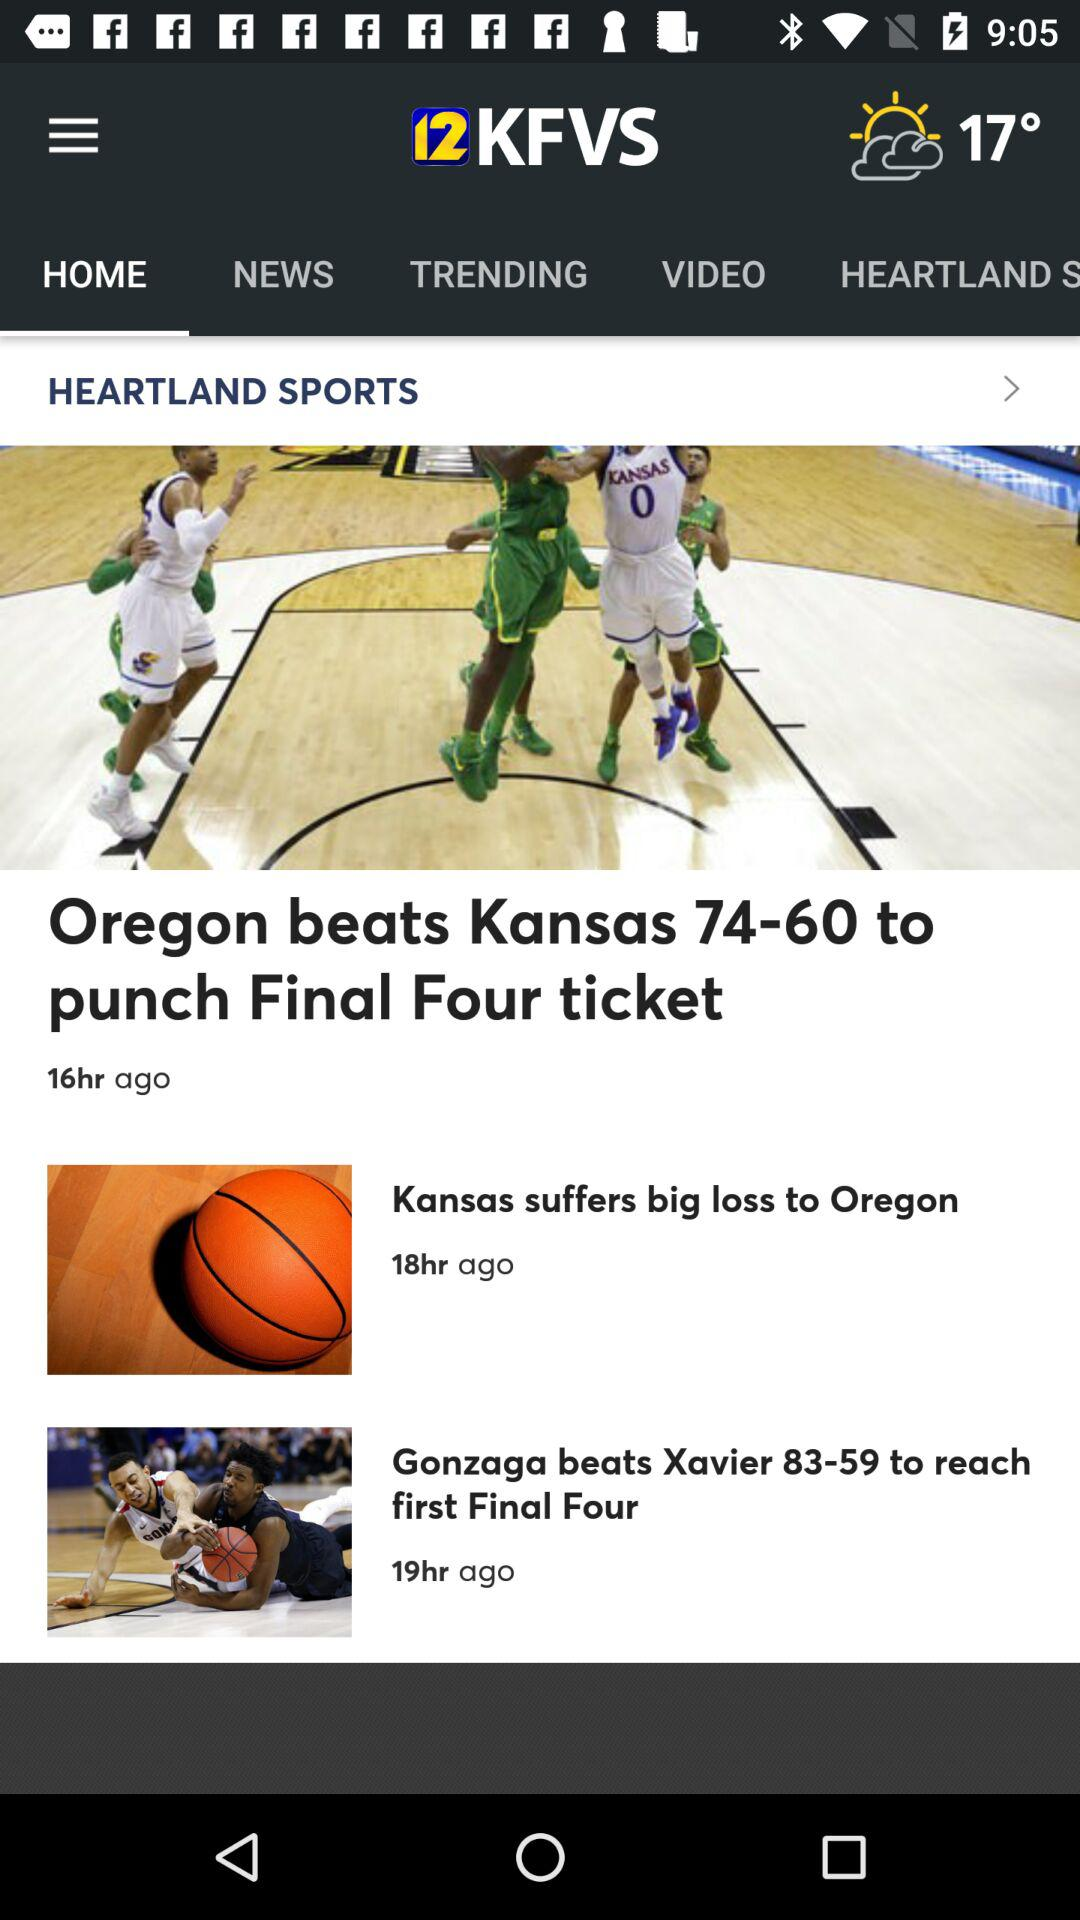When was the article "Oregon beats Kansas 74-60 to punch Final Four ticket" published? The article "Oregon beats Kansas 74-60 to punch Final Four ticket" was published 16 hours ago. 